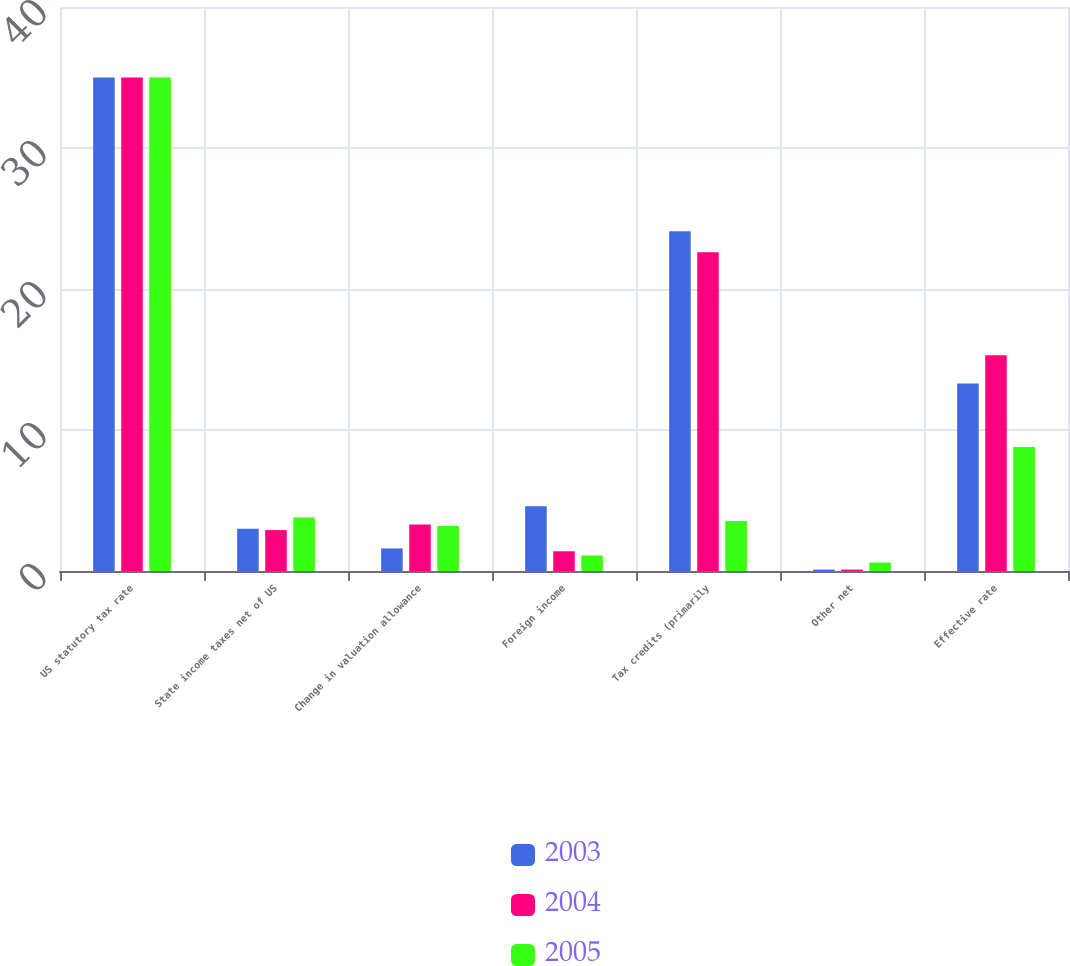<chart> <loc_0><loc_0><loc_500><loc_500><stacked_bar_chart><ecel><fcel>US statutory tax rate<fcel>State income taxes net of US<fcel>Change in valuation allowance<fcel>Foreign income<fcel>Tax credits (primarily<fcel>Other net<fcel>Effective rate<nl><fcel>2003<fcel>35<fcel>3<fcel>1.6<fcel>4.6<fcel>24.1<fcel>0.1<fcel>13.3<nl><fcel>2004<fcel>35<fcel>2.9<fcel>3.3<fcel>1.4<fcel>22.6<fcel>0.1<fcel>15.3<nl><fcel>2005<fcel>35<fcel>3.8<fcel>3.2<fcel>1.1<fcel>3.55<fcel>0.6<fcel>8.8<nl></chart> 